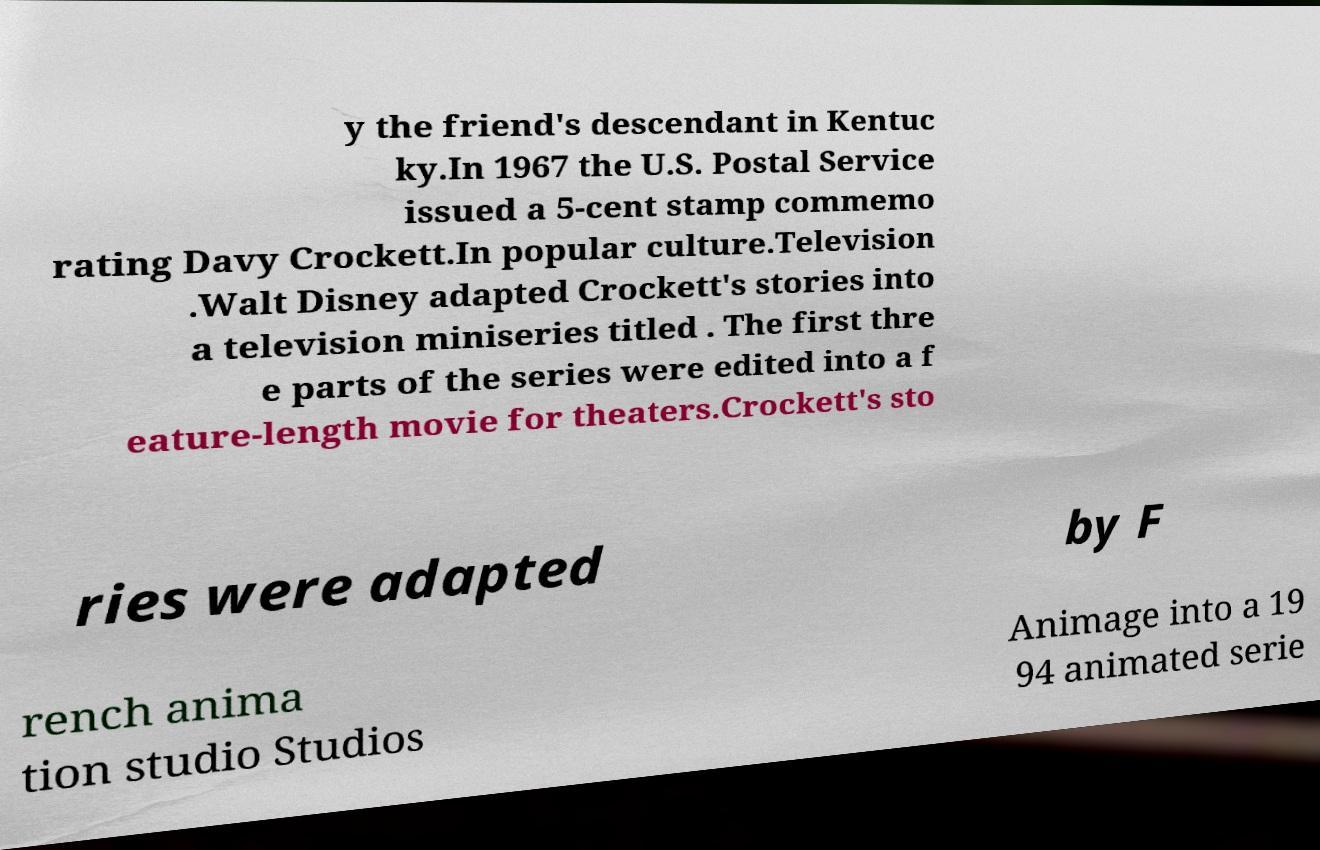Please read and relay the text visible in this image. What does it say? y the friend's descendant in Kentuc ky.In 1967 the U.S. Postal Service issued a 5-cent stamp commemo rating Davy Crockett.In popular culture.Television .Walt Disney adapted Crockett's stories into a television miniseries titled . The first thre e parts of the series were edited into a f eature-length movie for theaters.Crockett's sto ries were adapted by F rench anima tion studio Studios Animage into a 19 94 animated serie 